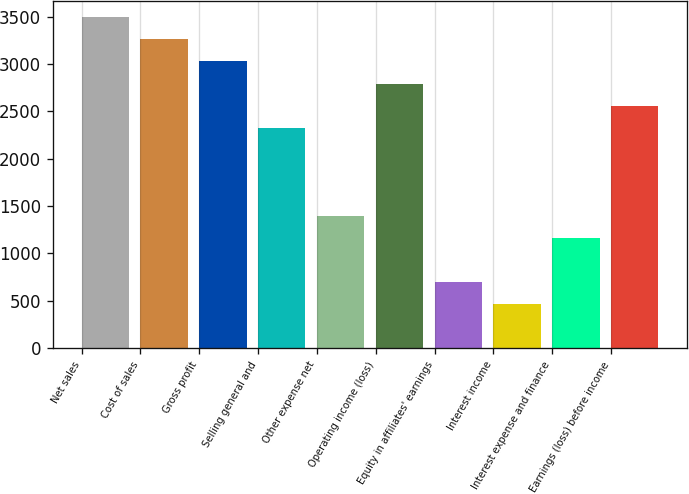Convert chart to OTSL. <chart><loc_0><loc_0><loc_500><loc_500><bar_chart><fcel>Net sales<fcel>Cost of sales<fcel>Gross profit<fcel>Selling general and<fcel>Other expense net<fcel>Operating income (loss)<fcel>Equity in affiliates' earnings<fcel>Interest income<fcel>Interest expense and finance<fcel>Earnings (loss) before income<nl><fcel>3493.36<fcel>3260.52<fcel>3027.68<fcel>2329.16<fcel>1397.8<fcel>2794.84<fcel>699.28<fcel>466.44<fcel>1164.96<fcel>2562<nl></chart> 